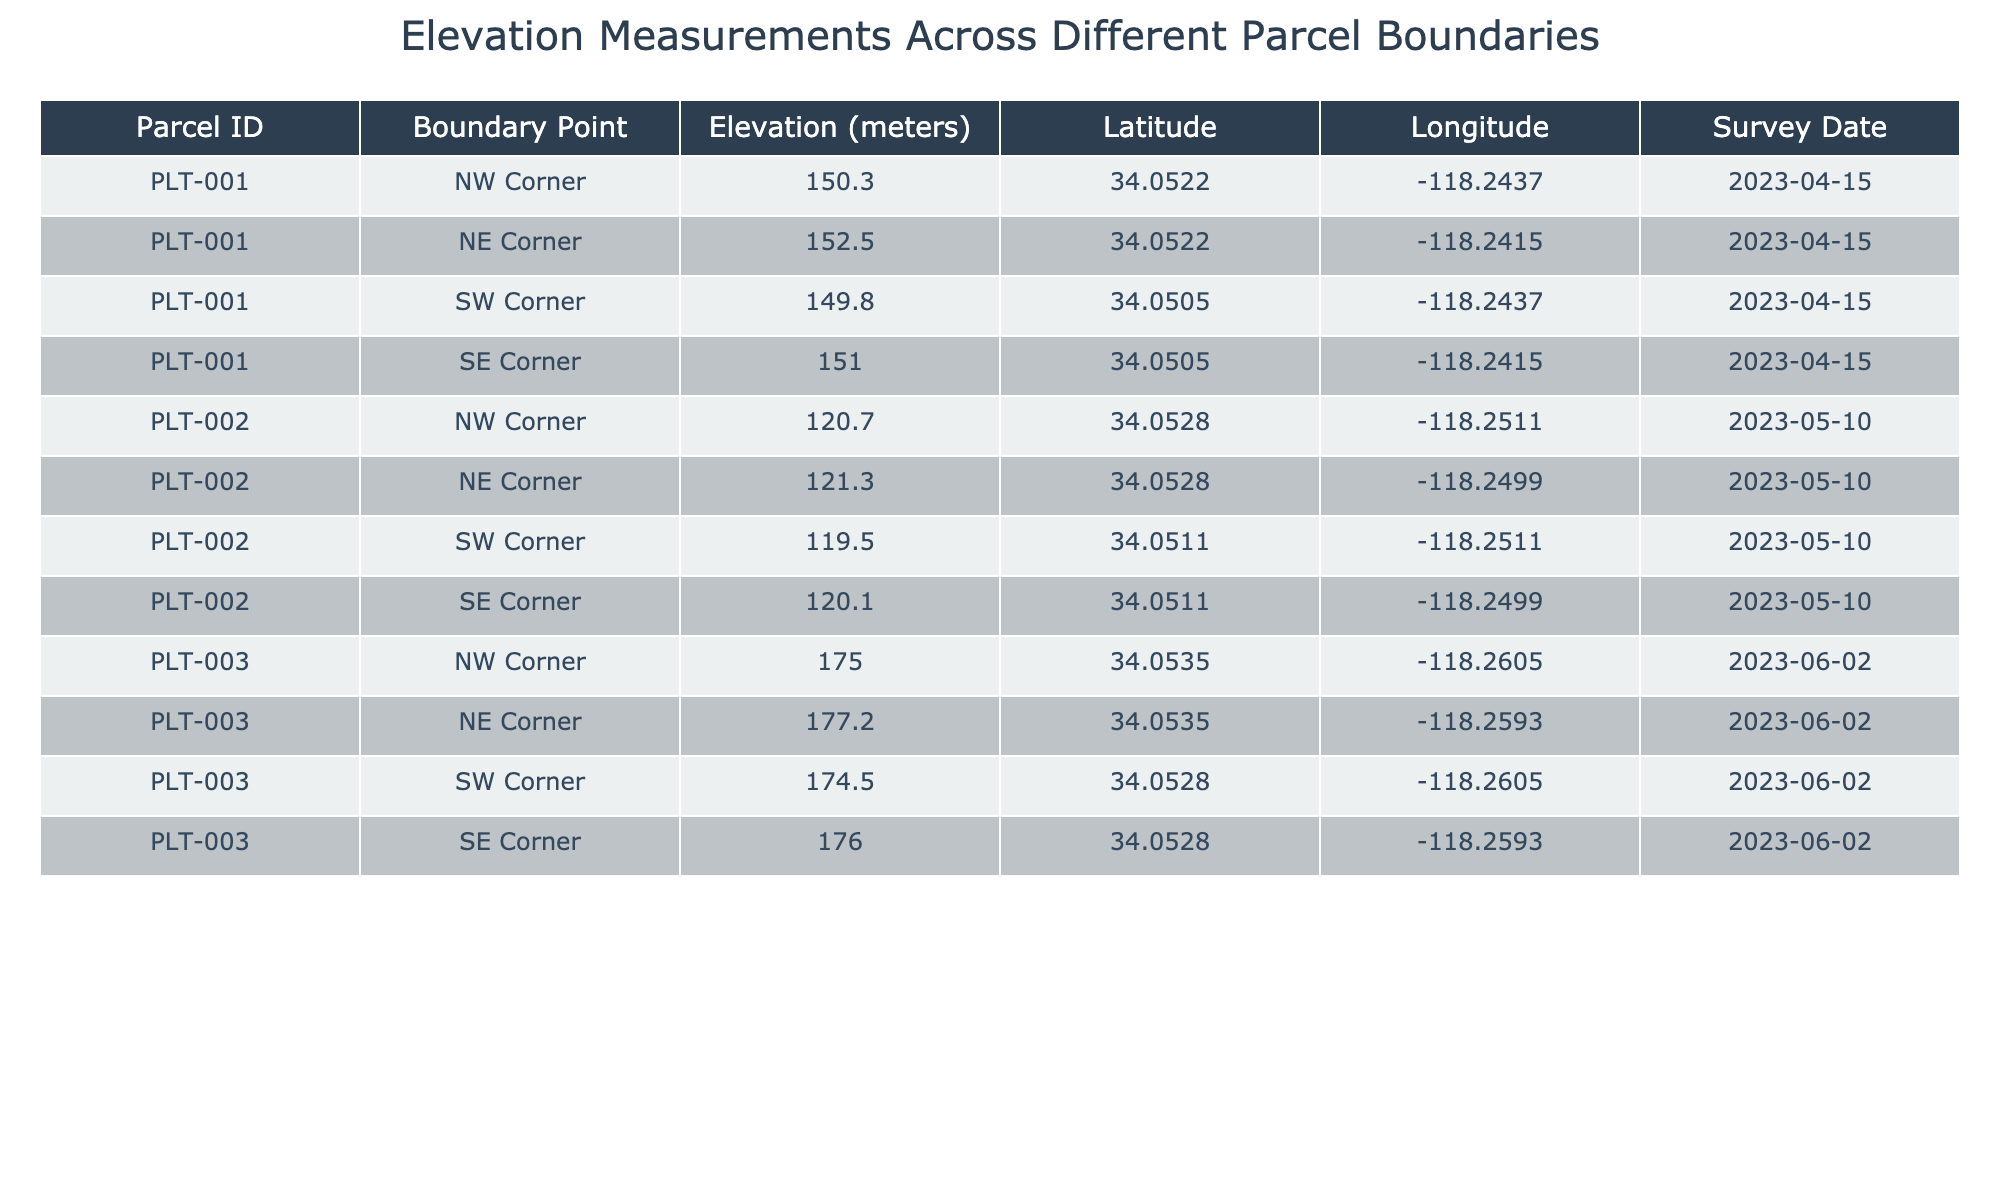What is the elevation at the NW Corner of Parcel ID PLT-001? The table shows that the elevation at the NW Corner for Parcel PLT-001 is listed directly under the corresponding columns, which is 150.3 meters.
Answer: 150.3 meters What is the maximum elevation recorded across all parcels? To find the maximum elevation, we look for the highest number in the Elevation column. The maximum value from the data is 177.2 meters found at the NE Corner of Parcel PLT-003.
Answer: 177.2 meters What is the average elevation of Parcel ID PLT-002? The elevations for Parcel PLT-002 are 120.7, 121.3, 119.5, and 120.1 meters. Summing these values gives 481.6 meters. There are 4 points, so the average is 481.6 / 4 = 120.4 meters.
Answer: 120.4 meters Is the elevation at the SE Corner of Parcel ID PLT-003 higher than the NE Corner of Parcel ID PLT-002? The elevation at the SE Corner of Parcel PLT-003 is 176.0 meters, while the NE Corner of Parcel PLT-002 is 121.3 meters. Since 176.0 is greater than 121.3, the statement is true.
Answer: Yes What is the difference in elevation between the NE Corner of Parcel ID PLT-001 and the SW Corner of Parcel ID PLT-003? The elevation at the NE Corner of PLT-001 is 152.5 meters and at the SW Corner of PLT-003 it's 174.5 meters. The difference is calculated as 174.5 - 152.5 = 22.0 meters.
Answer: 22.0 meters Is the elevation at the SW Corner of Parcel ID PLT-002 greater than the maximum elevation at Parcel ID PLT-001? The elevation at the SW Corner of PLT-002 is 119.5 meters, while the maximum elevation for PLT-001 is 152.5 meters at the NE Corner. Since 119.5 is less than 152.5, the statement is false.
Answer: No What are the elevation measurements for the SE Corners of all parcels? The table lists the elevations: for PLT-001 it is 151.0, for PLT-002 it is 120.1, and for PLT-003 it is 176.0 meters.
Answer: 151.0, 120.1, 176.0 meters How many survey dates are listed in the table? The table includes four different survey dates: 2023-04-15, 2023-05-10, and 2023-06-02. Counting these gives a total of three unique dates.
Answer: 3 What is the relationship between the elevation at the NW Corner of Parcel ID PLT-002 and the average elevation of Parcel ID PLT-003? The elevation at the NW Corner of PLT-002 is 120.7 meters. The average elevation of PLT-003 is calculated as (175.0 + 177.2 + 174.5 + 176.0) / 4 = 175.675 meters. Since 120.7 is less than 175.675, the relationship shows PLT-002 has a lower NW Corner elevation.
Answer: PLT-002 is lower 